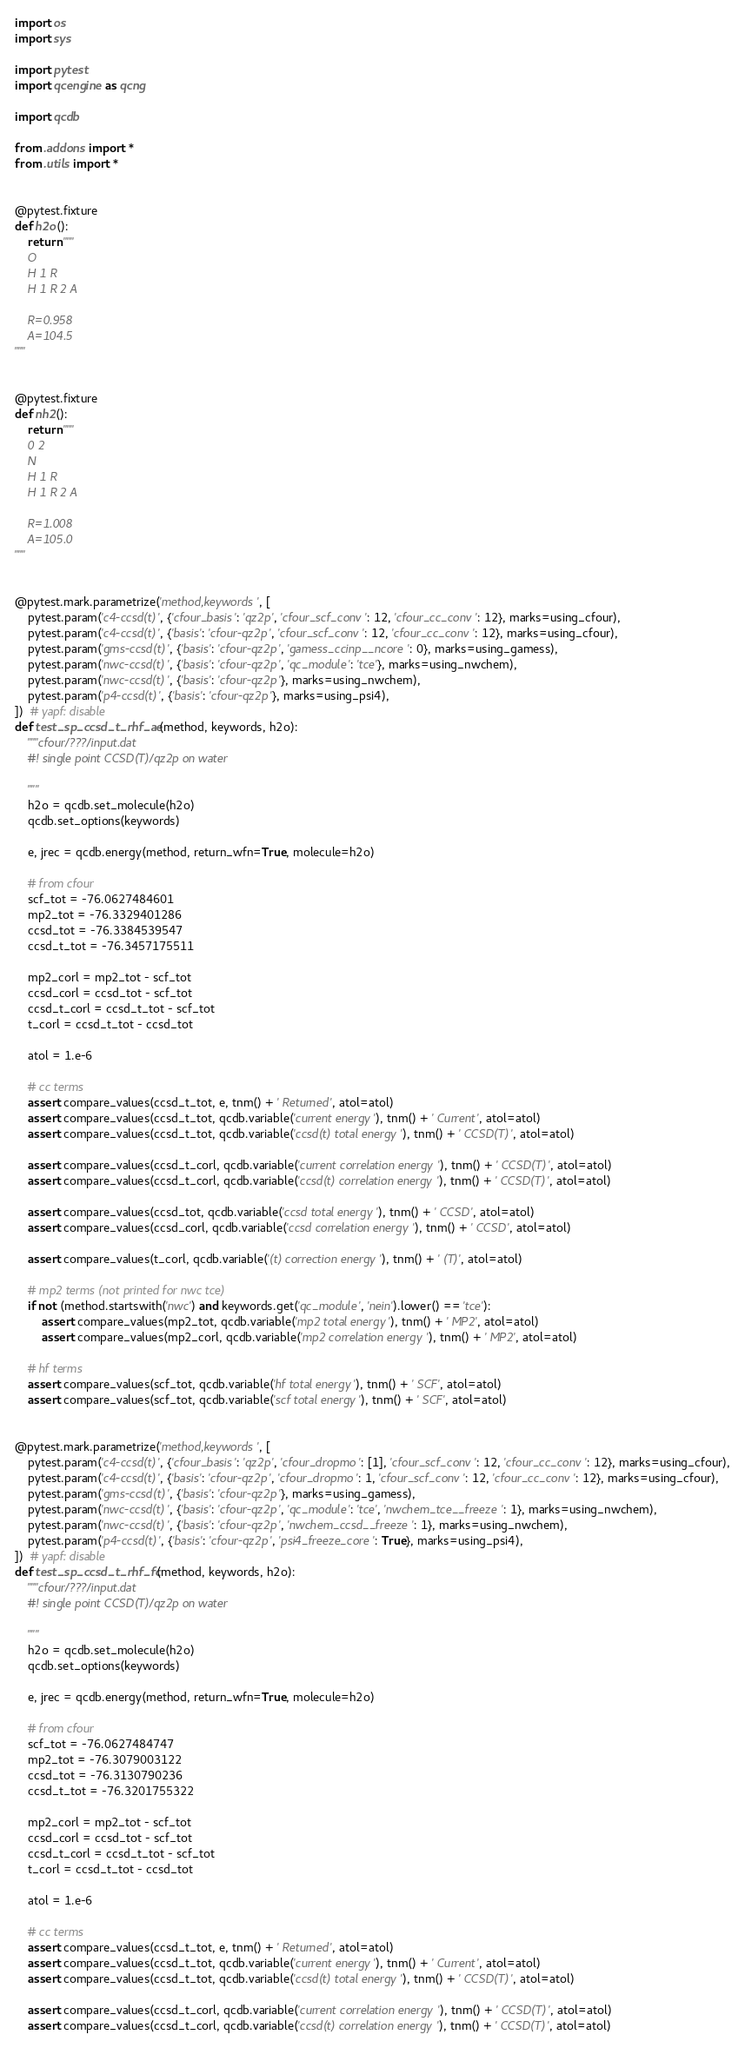<code> <loc_0><loc_0><loc_500><loc_500><_Python_>import os
import sys

import pytest
import qcengine as qcng

import qcdb

from .addons import *
from .utils import *


@pytest.fixture
def h2o():
    return """
    O
    H 1 R
    H 1 R 2 A

    R=0.958
    A=104.5
"""


@pytest.fixture
def nh2():
    return """
    0 2
    N
    H 1 R
    H 1 R 2 A

    R=1.008
    A=105.0
"""


@pytest.mark.parametrize('method,keywords', [
    pytest.param('c4-ccsd(t)', {'cfour_basis': 'qz2p', 'cfour_scf_conv': 12, 'cfour_cc_conv': 12}, marks=using_cfour),
    pytest.param('c4-ccsd(t)', {'basis': 'cfour-qz2p', 'cfour_scf_conv': 12, 'cfour_cc_conv': 12}, marks=using_cfour),
    pytest.param('gms-ccsd(t)', {'basis': 'cfour-qz2p', 'gamess_ccinp__ncore': 0}, marks=using_gamess),
    pytest.param('nwc-ccsd(t)', {'basis': 'cfour-qz2p', 'qc_module': 'tce'}, marks=using_nwchem),
    pytest.param('nwc-ccsd(t)', {'basis': 'cfour-qz2p'}, marks=using_nwchem),
    pytest.param('p4-ccsd(t)', {'basis': 'cfour-qz2p'}, marks=using_psi4),
])  # yapf: disable
def test_sp_ccsd_t_rhf_ae(method, keywords, h2o):
    """cfour/???/input.dat
    #! single point CCSD(T)/qz2p on water

    """
    h2o = qcdb.set_molecule(h2o)
    qcdb.set_options(keywords)

    e, jrec = qcdb.energy(method, return_wfn=True, molecule=h2o)

    # from cfour
    scf_tot = -76.0627484601
    mp2_tot = -76.3329401286
    ccsd_tot = -76.3384539547
    ccsd_t_tot = -76.3457175511

    mp2_corl = mp2_tot - scf_tot
    ccsd_corl = ccsd_tot - scf_tot
    ccsd_t_corl = ccsd_t_tot - scf_tot
    t_corl = ccsd_t_tot - ccsd_tot

    atol = 1.e-6

    # cc terms
    assert compare_values(ccsd_t_tot, e, tnm() + ' Returned', atol=atol)
    assert compare_values(ccsd_t_tot, qcdb.variable('current energy'), tnm() + ' Current', atol=atol)
    assert compare_values(ccsd_t_tot, qcdb.variable('ccsd(t) total energy'), tnm() + ' CCSD(T)', atol=atol)

    assert compare_values(ccsd_t_corl, qcdb.variable('current correlation energy'), tnm() + ' CCSD(T)', atol=atol)
    assert compare_values(ccsd_t_corl, qcdb.variable('ccsd(t) correlation energy'), tnm() + ' CCSD(T)', atol=atol)

    assert compare_values(ccsd_tot, qcdb.variable('ccsd total energy'), tnm() + ' CCSD', atol=atol)
    assert compare_values(ccsd_corl, qcdb.variable('ccsd correlation energy'), tnm() + ' CCSD', atol=atol)

    assert compare_values(t_corl, qcdb.variable('(t) correction energy'), tnm() + ' (T)', atol=atol)

    # mp2 terms (not printed for nwc tce)
    if not (method.startswith('nwc') and keywords.get('qc_module', 'nein').lower() == 'tce'):
        assert compare_values(mp2_tot, qcdb.variable('mp2 total energy'), tnm() + ' MP2', atol=atol)
        assert compare_values(mp2_corl, qcdb.variable('mp2 correlation energy'), tnm() + ' MP2', atol=atol)

    # hf terms
    assert compare_values(scf_tot, qcdb.variable('hf total energy'), tnm() + ' SCF', atol=atol)
    assert compare_values(scf_tot, qcdb.variable('scf total energy'), tnm() + ' SCF', atol=atol)


@pytest.mark.parametrize('method,keywords', [
    pytest.param('c4-ccsd(t)', {'cfour_basis': 'qz2p', 'cfour_dropmo': [1], 'cfour_scf_conv': 12, 'cfour_cc_conv': 12}, marks=using_cfour),
    pytest.param('c4-ccsd(t)', {'basis': 'cfour-qz2p', 'cfour_dropmo': 1, 'cfour_scf_conv': 12, 'cfour_cc_conv': 12}, marks=using_cfour),
    pytest.param('gms-ccsd(t)', {'basis': 'cfour-qz2p'}, marks=using_gamess),
    pytest.param('nwc-ccsd(t)', {'basis': 'cfour-qz2p', 'qc_module': 'tce', 'nwchem_tce__freeze': 1}, marks=using_nwchem),
    pytest.param('nwc-ccsd(t)', {'basis': 'cfour-qz2p', 'nwchem_ccsd__freeze': 1}, marks=using_nwchem),
    pytest.param('p4-ccsd(t)', {'basis': 'cfour-qz2p', 'psi4_freeze_core': True}, marks=using_psi4),
])  # yapf: disable
def test_sp_ccsd_t_rhf_fc(method, keywords, h2o):
    """cfour/???/input.dat
    #! single point CCSD(T)/qz2p on water

    """
    h2o = qcdb.set_molecule(h2o)
    qcdb.set_options(keywords)

    e, jrec = qcdb.energy(method, return_wfn=True, molecule=h2o)

    # from cfour
    scf_tot = -76.0627484747
    mp2_tot = -76.3079003122
    ccsd_tot = -76.3130790236
    ccsd_t_tot = -76.3201755322

    mp2_corl = mp2_tot - scf_tot
    ccsd_corl = ccsd_tot - scf_tot
    ccsd_t_corl = ccsd_t_tot - scf_tot
    t_corl = ccsd_t_tot - ccsd_tot

    atol = 1.e-6

    # cc terms
    assert compare_values(ccsd_t_tot, e, tnm() + ' Returned', atol=atol)
    assert compare_values(ccsd_t_tot, qcdb.variable('current energy'), tnm() + ' Current', atol=atol)
    assert compare_values(ccsd_t_tot, qcdb.variable('ccsd(t) total energy'), tnm() + ' CCSD(T)', atol=atol)

    assert compare_values(ccsd_t_corl, qcdb.variable('current correlation energy'), tnm() + ' CCSD(T)', atol=atol)
    assert compare_values(ccsd_t_corl, qcdb.variable('ccsd(t) correlation energy'), tnm() + ' CCSD(T)', atol=atol)
</code> 